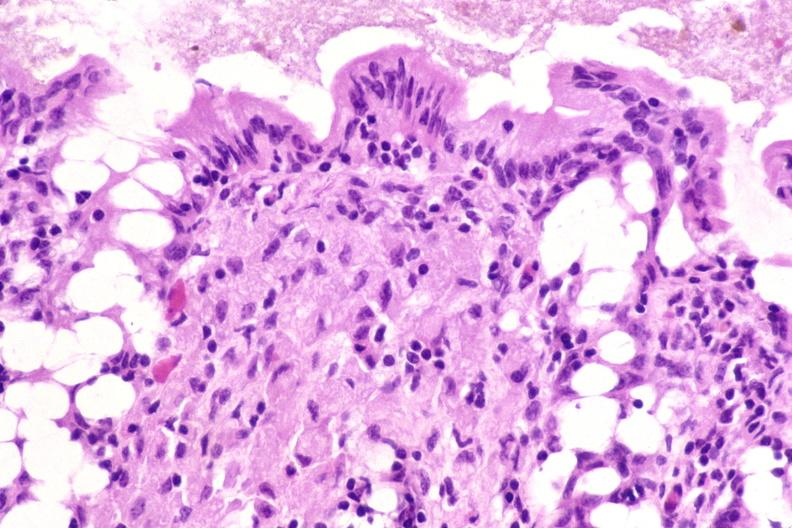do iron stain?
Answer the question using a single word or phrase. No 